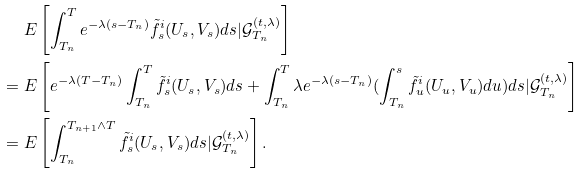Convert formula to latex. <formula><loc_0><loc_0><loc_500><loc_500>& \ E \left [ \int _ { T _ { n } } ^ { T } e ^ { - \lambda ( s - T _ { n } ) } \tilde { f } _ { s } ^ { i } ( U _ { s } , V _ { s } ) d s | \mathcal { G } _ { T _ { n } } ^ { ( t , \lambda ) } \right ] \\ = & \ E \left [ e ^ { - \lambda ( T - T _ { n } ) } \int _ { T _ { n } } ^ { T } \tilde { f } _ { s } ^ { i } ( U _ { s } , V _ { s } ) d s + \int _ { T _ { n } } ^ { T } \lambda e ^ { - \lambda ( s - T _ { n } ) } ( \int _ { T _ { n } } ^ { s } \tilde { f } _ { u } ^ { i } ( U _ { u } , V _ { u } ) d u ) d s | \mathcal { G } _ { T _ { n } } ^ { ( t , \lambda ) } \right ] \\ = & \ E \left [ \int _ { T _ { n } } ^ { T _ { n + 1 } \wedge T } \tilde { f } _ { s } ^ { i } ( U _ { s } , V _ { s } ) d s | \mathcal { G } _ { T _ { n } } ^ { ( t , \lambda ) } \right ] .</formula> 